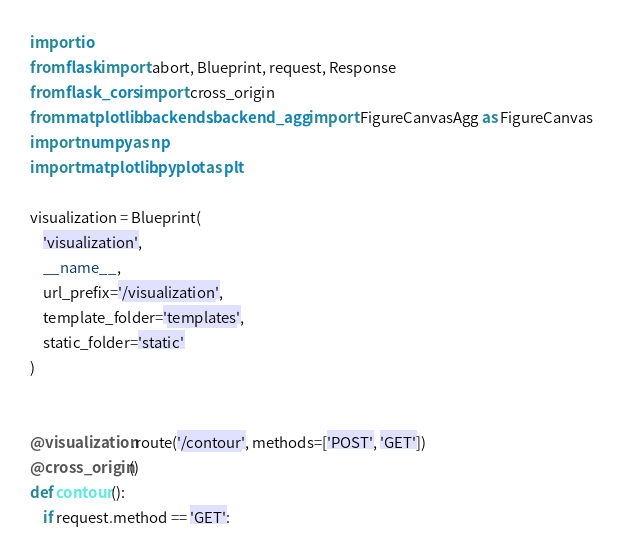<code> <loc_0><loc_0><loc_500><loc_500><_Python_>import io
from flask import abort, Blueprint, request, Response
from flask_cors import cross_origin
from matplotlib.backends.backend_agg import FigureCanvasAgg as FigureCanvas
import numpy as np
import matplotlib.pyplot as plt

visualization = Blueprint(
    'visualization',
    __name__,
    url_prefix='/visualization',
    template_folder='templates',
    static_folder='static'
)


@visualization.route('/contour', methods=['POST', 'GET'])
@cross_origin()
def contour():
    if request.method == 'GET':</code> 